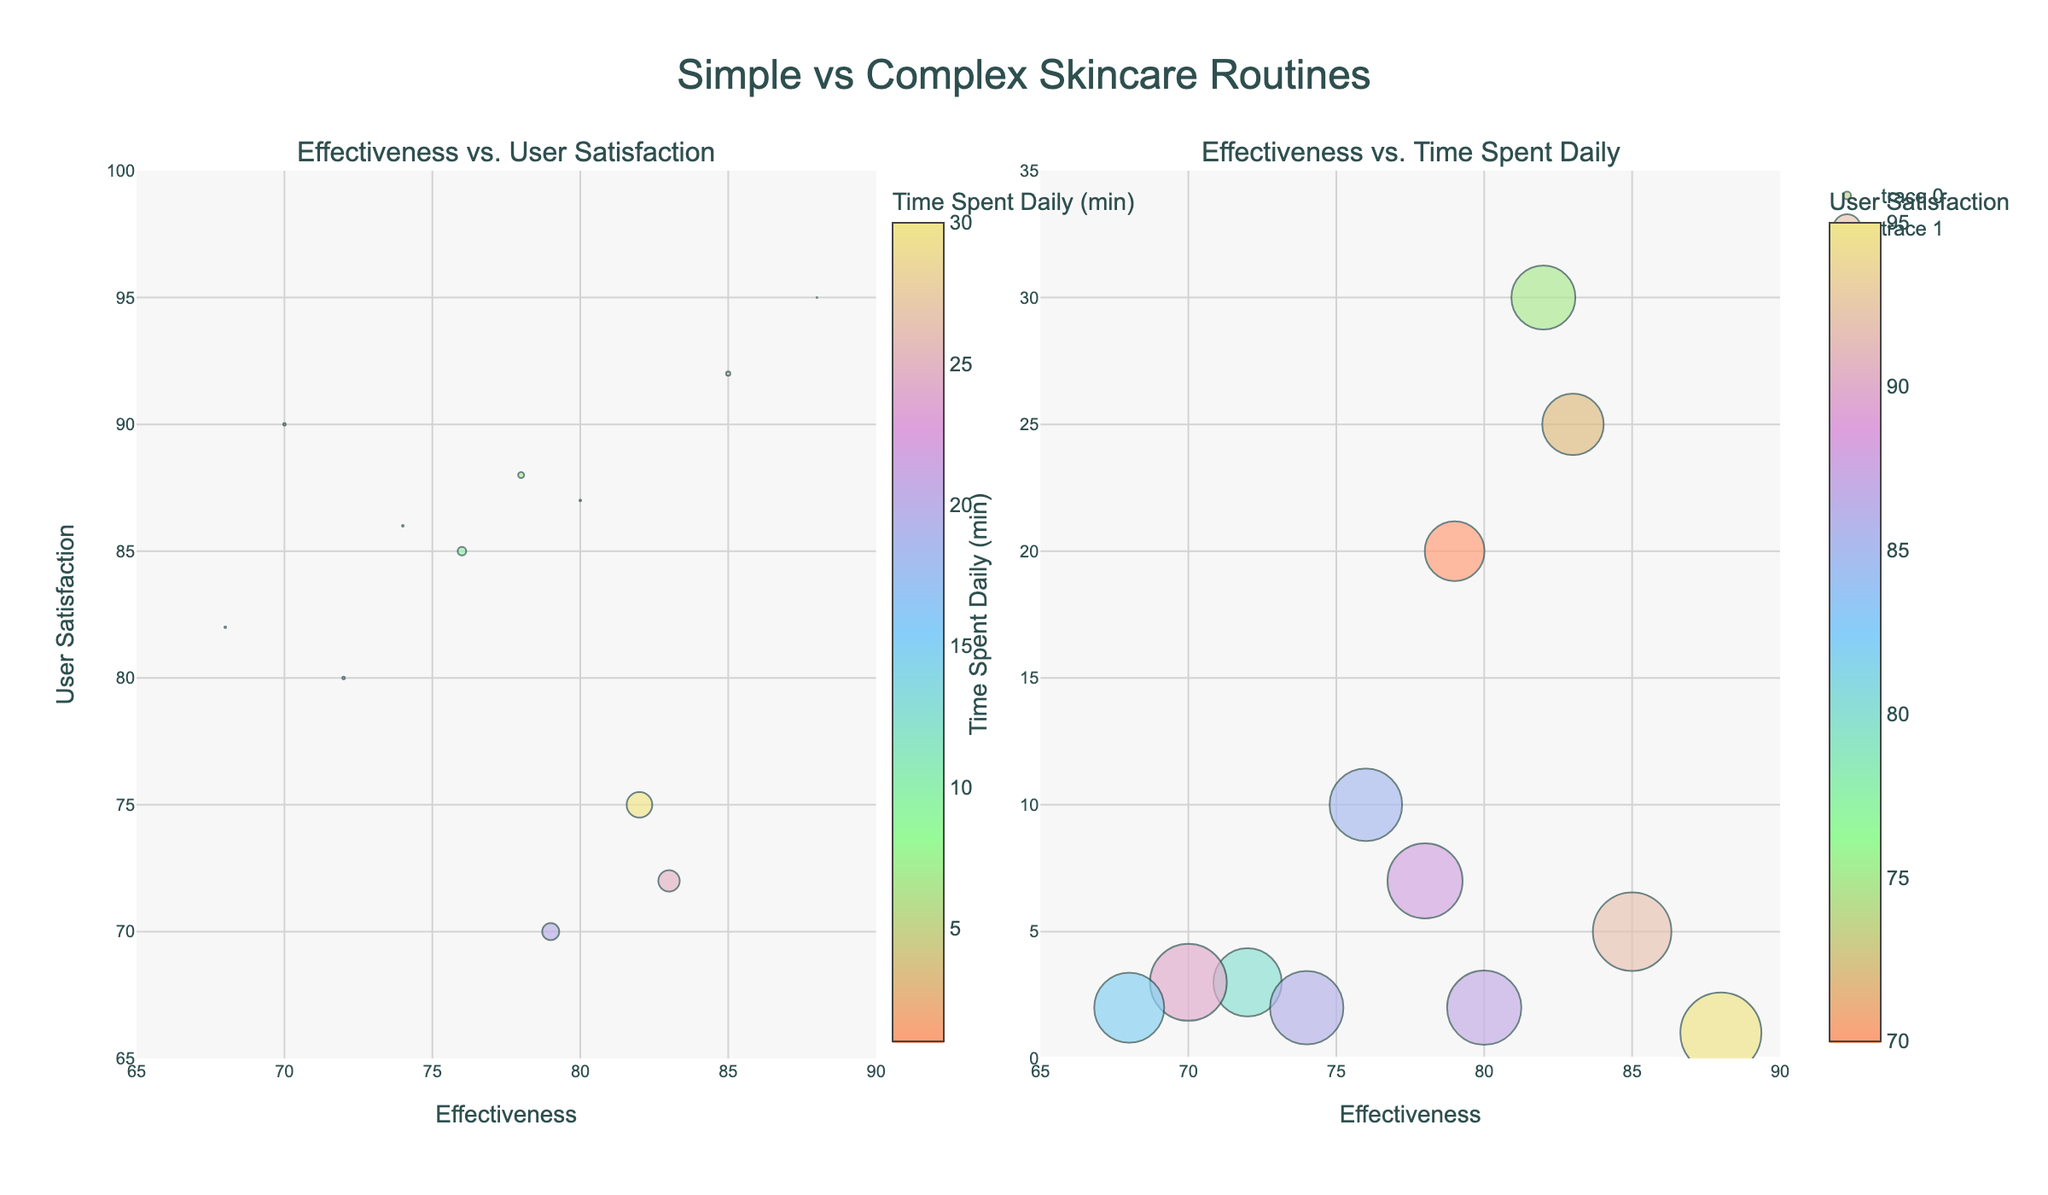What's the main title of the plot? The main title is displayed at the top center of the figure, it reads "Simple vs Complex Skincare Routines".
Answer: "Simple vs Complex Skincare Routines" What is the range of the x-axis in the left subplot? The x-axis on the left subplot starts at 65 and goes up to 90.
Answer: 65 to 90 Which routine spends the least amount of time daily? By looking at the data points in both subplots, "Simple SPF Application" has the smallest bubble size indicating it spends the least time, which is 1 minute daily.
Answer: Simple SPF Application How many routines have an effectiveness greater than 80? Examine the x-axis in both subplots, and count the number of data points where the effectiveness value is greater than 80. There are 6 routines: "Simple Cleanse and Moisturize", "Korean 10-Step Routine", "Retinol Night Cream", "Simple SPF Application", "Extensive Anti-Aging Regimen", and "Complex Multi-Acid Peel".
Answer: 6 What routine has the highest user satisfaction? In the left subplot, find the data point with the highest y-axis value. The routine with the highest user satisfaction is "Simple SPF Application" with a satisfaction score of 95.
Answer: Simple SPF Application Which routine is the least effective? Check the data points on the x-axis in both subplots and find the one with the lowest effectiveness value. "Rose Water Toner" has the lowest effectiveness score of 68.
Answer: Rose Water Toner Is there a routine that ranks high in effectiveness but low in user satisfaction? Look for a data point on the x-axis (effectiveness) with a high value but a low y-axis (user satisfaction) value on the left subplot. "Korean 10-Step Routine" fits this with high effectiveness (82) but relatively low user satisfaction (75).
Answer: Korean 10-Step Routine What routine spends the most time daily? In the right subplot, the data point with the highest y-axis value corresponds to the routine "Korean 10-Step Routine," which spends 30 minutes daily.
Answer: Korean 10-Step Routine Compare the user satisfaction between "Oil Cleansing Method" and "Extensive Anti-Aging Regimen". Which is higher? In the left subplot, find the y-values for both routines. "Oil Cleansing Method" has a user satisfaction of 88, while "Extensive Anti-Aging Regimen" has 72. So "Oil Cleansing Method" has a higher user satisfaction.
Answer: Oil Cleansing Method has higher user satisfaction Which routine has moderate effectiveness and high user satisfaction? Check the middle range of x-axis values for effectiveness and upper range of y-axis for user satisfaction in the left subplot. "Aloe Vera Gel" fits this with moderate effectiveness (74) and high user satisfaction (86).
Answer: Aloe Vera Gel 